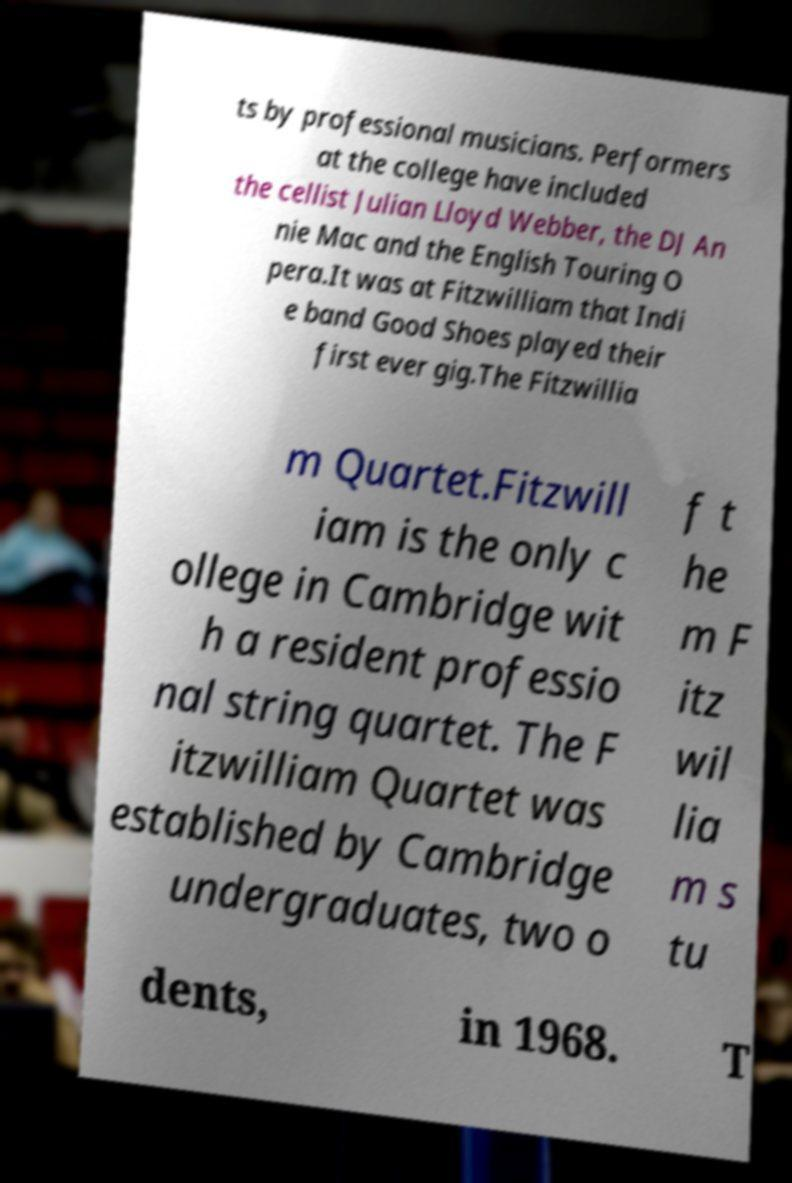Please read and relay the text visible in this image. What does it say? ts by professional musicians. Performers at the college have included the cellist Julian Lloyd Webber, the DJ An nie Mac and the English Touring O pera.It was at Fitzwilliam that Indi e band Good Shoes played their first ever gig.The Fitzwillia m Quartet.Fitzwill iam is the only c ollege in Cambridge wit h a resident professio nal string quartet. The F itzwilliam Quartet was established by Cambridge undergraduates, two o f t he m F itz wil lia m s tu dents, in 1968. T 